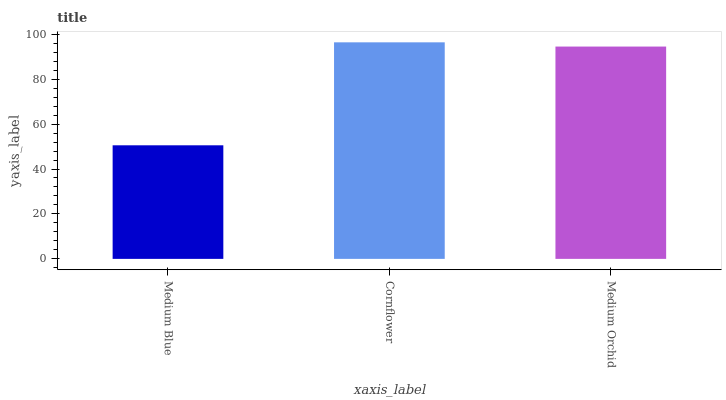Is Medium Blue the minimum?
Answer yes or no. Yes. Is Cornflower the maximum?
Answer yes or no. Yes. Is Medium Orchid the minimum?
Answer yes or no. No. Is Medium Orchid the maximum?
Answer yes or no. No. Is Cornflower greater than Medium Orchid?
Answer yes or no. Yes. Is Medium Orchid less than Cornflower?
Answer yes or no. Yes. Is Medium Orchid greater than Cornflower?
Answer yes or no. No. Is Cornflower less than Medium Orchid?
Answer yes or no. No. Is Medium Orchid the high median?
Answer yes or no. Yes. Is Medium Orchid the low median?
Answer yes or no. Yes. Is Cornflower the high median?
Answer yes or no. No. Is Cornflower the low median?
Answer yes or no. No. 